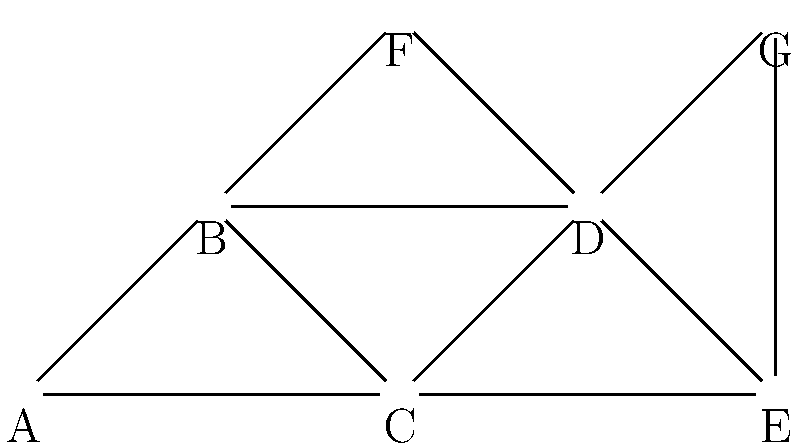In the given network diagram representing disease transmission patterns, which individual (node) has the highest degree centrality, and what does this imply about their role in the disease spread? To answer this question, we need to follow these steps:

1. Understand degree centrality:
   Degree centrality is the number of direct connections a node has in a network.

2. Count connections for each node:
   A: 2 connections (B, C)
   B: 4 connections (A, C, D, F)
   C: 4 connections (A, B, D, E)
   D: 5 connections (B, C, E, F, G)
   E: 3 connections (C, D, G)
   F: 2 connections (B, D)
   G: 2 connections (D, E)

3. Identify the node with the highest degree centrality:
   Node D has the highest degree centrality with 5 connections.

4. Interpret the implications:
   The node with the highest degree centrality (D) represents an individual who has the most direct contacts in the network. In the context of disease transmission, this person:
   a) Has the highest potential to both contract and spread the disease.
   b) Acts as a hub in the network, potentially accelerating disease spread.
   c) Could be a priority target for intervention strategies (e.g., vaccination, isolation, or education).
   d) Might be a key individual for contact tracing efforts.

5. Consider the public health perspective:
   As a public health official, identifying individuals with high degree centrality is crucial for:
   a) Predicting potential superspreader events.
   b) Allocating resources efficiently for disease control.
   c) Designing targeted intervention strategies.
   d) Understanding the overall structure of disease transmission in the community.
Answer: Node D; highest potential for disease spread and key target for intervention. 